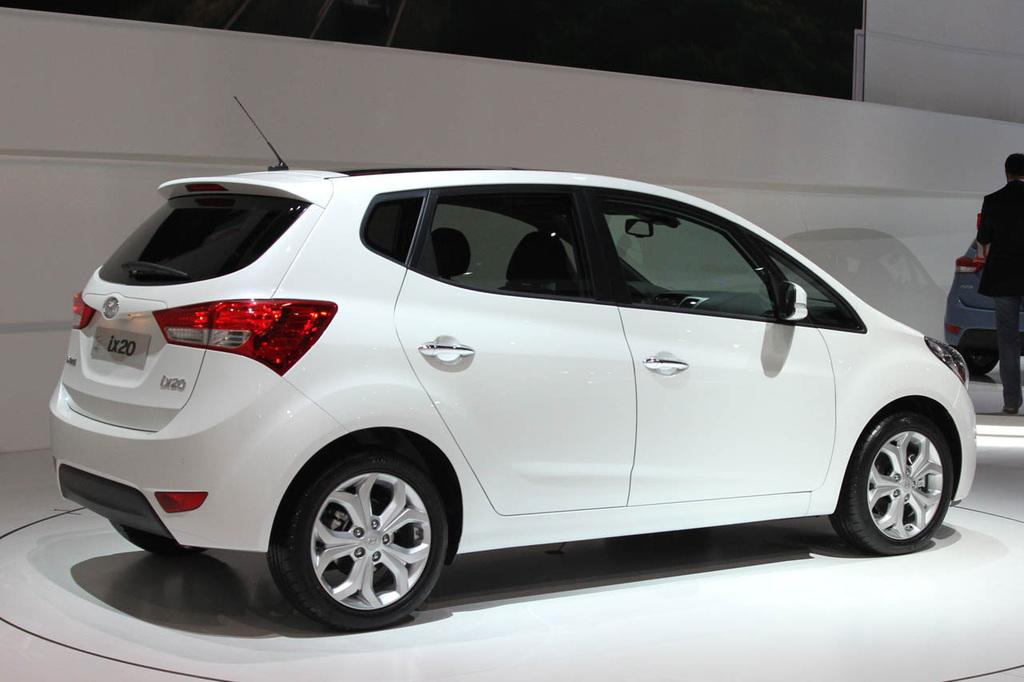What is the main subject in the foreground of the image? There is a white color car in the foreground of the image. What is the color of the surface the car is on? The car is on a white surface. What can be seen in the background of the image? There is a wall in the background of the image, and a man is standing there. Are there any other cars visible in the image? Yes, there is another car on the right side in the background. What type of zipper can be seen on the car in the image? There are no zippers present on the car in the image. Is there a police officer standing next to the man in the background? There is no mention of a police officer in the image; only a man is standing in the background. 